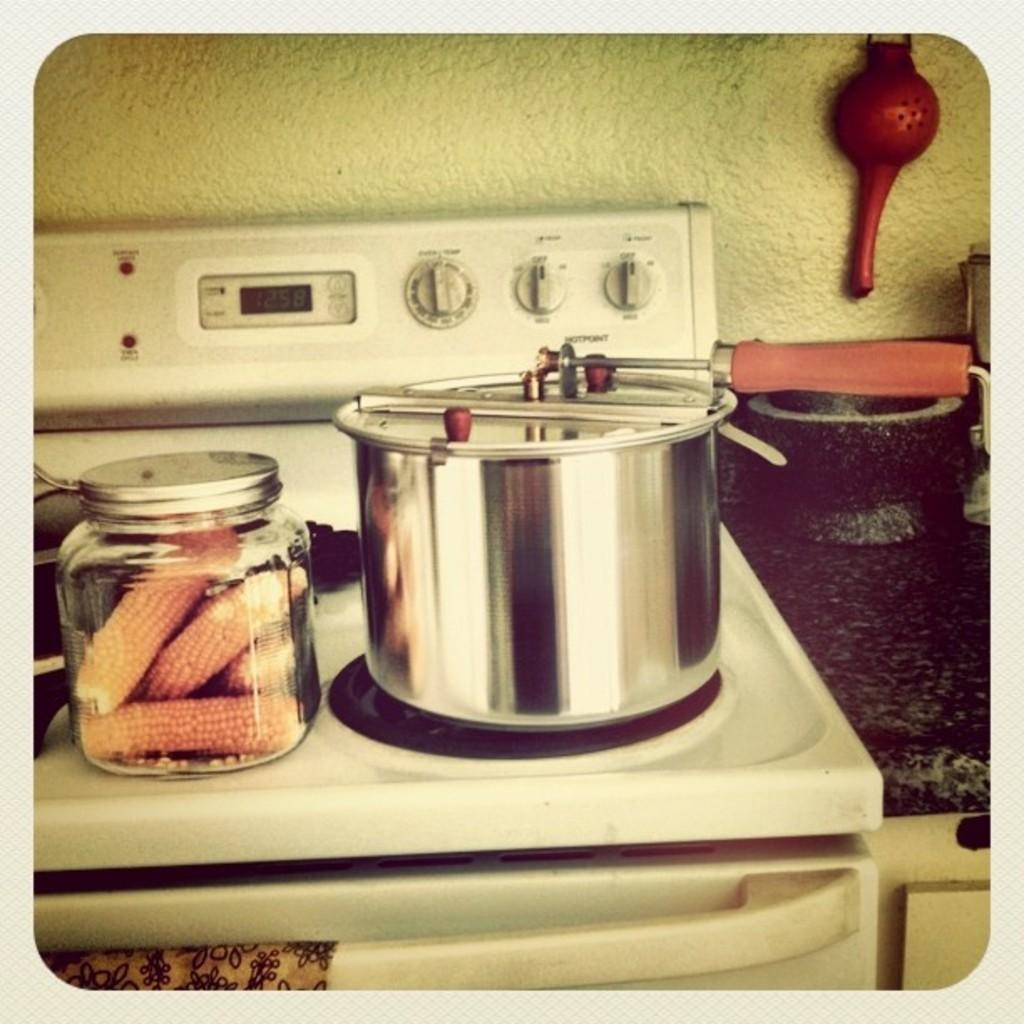<image>
Provide a brief description of the given image. A pot and a jar of corn on a stove which shows that the time is 12:58. 